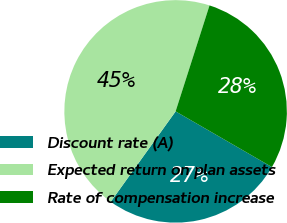Convert chart. <chart><loc_0><loc_0><loc_500><loc_500><pie_chart><fcel>Discount rate (A)<fcel>Expected return on plan assets<fcel>Rate of compensation increase<nl><fcel>26.57%<fcel>45.02%<fcel>28.41%<nl></chart> 